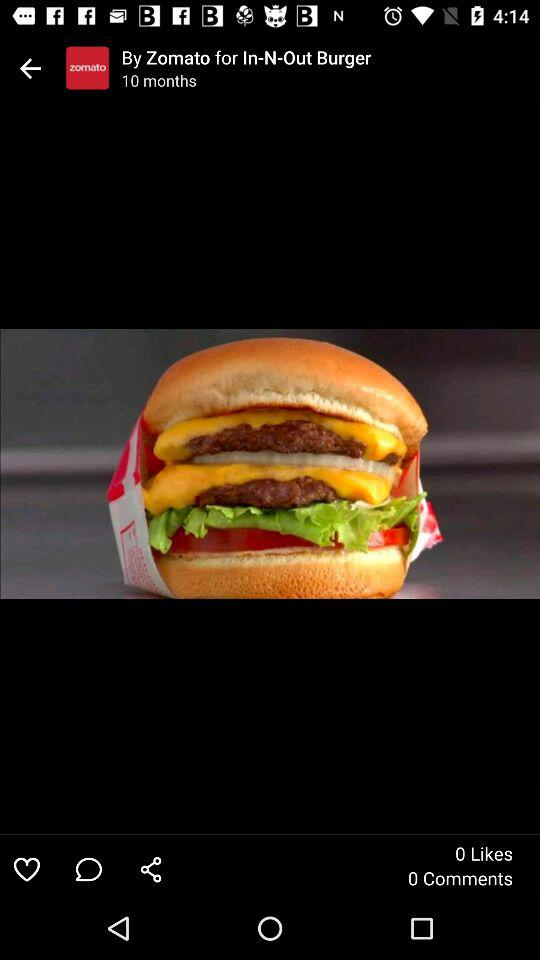How many likes and comments are given? The given likes and comments are 0 and 0, respectively. 